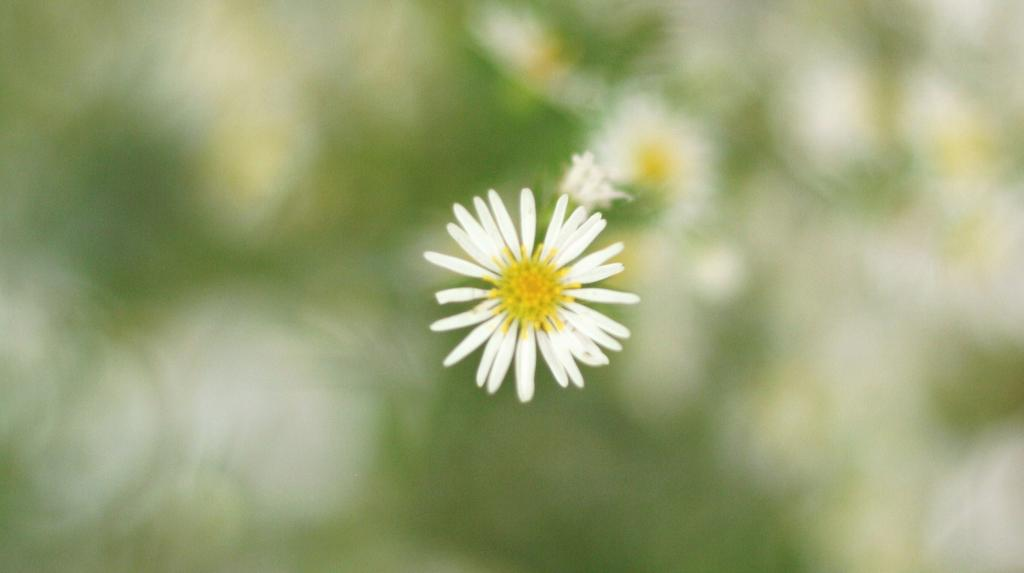What type of flower is in the picture? There is a white sunflower in the picture. Where is the sunflower located in the image? The sunflower is in the middle of the image. What type of chair is visible in the image? There is no chair present in the image; it only features a white sunflower. What things are burning in the image? There are no things burning in the image; it only features a white sunflower. 